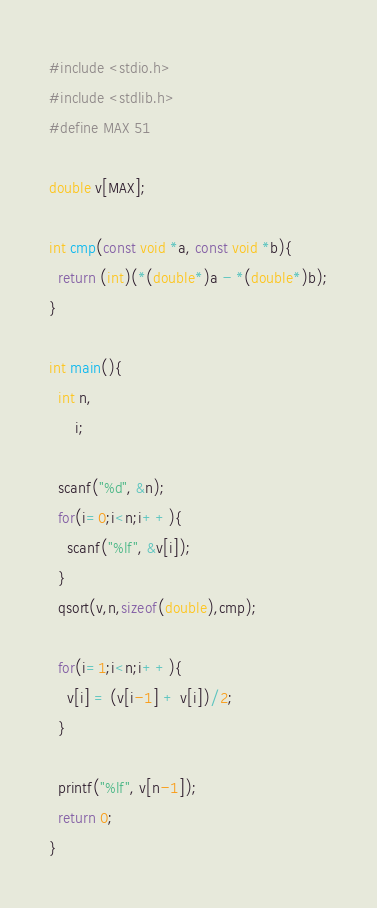<code> <loc_0><loc_0><loc_500><loc_500><_C_>#include <stdio.h>
#include <stdlib.h>
#define MAX 51

double v[MAX];

int cmp(const void *a, const void *b){
  return (int)(*(double*)a - *(double*)b);
}

int main(){
  int n,
      i;
  
  scanf("%d", &n);
  for(i=0;i<n;i++){
    scanf("%lf", &v[i]);
  }
  qsort(v,n,sizeof(double),cmp);
  
  for(i=1;i<n;i++){
    v[i] = (v[i-1] + v[i])/2;
  }
  
  printf("%lf", v[n-1]); 
  return 0;
}</code> 